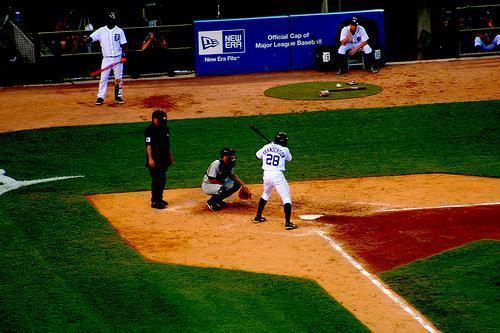How many batters are there?
Give a very brief answer. 1. 